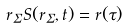<formula> <loc_0><loc_0><loc_500><loc_500>r _ { \Sigma } S ( r _ { \Sigma } , t ) = { r } ( \tau )</formula> 